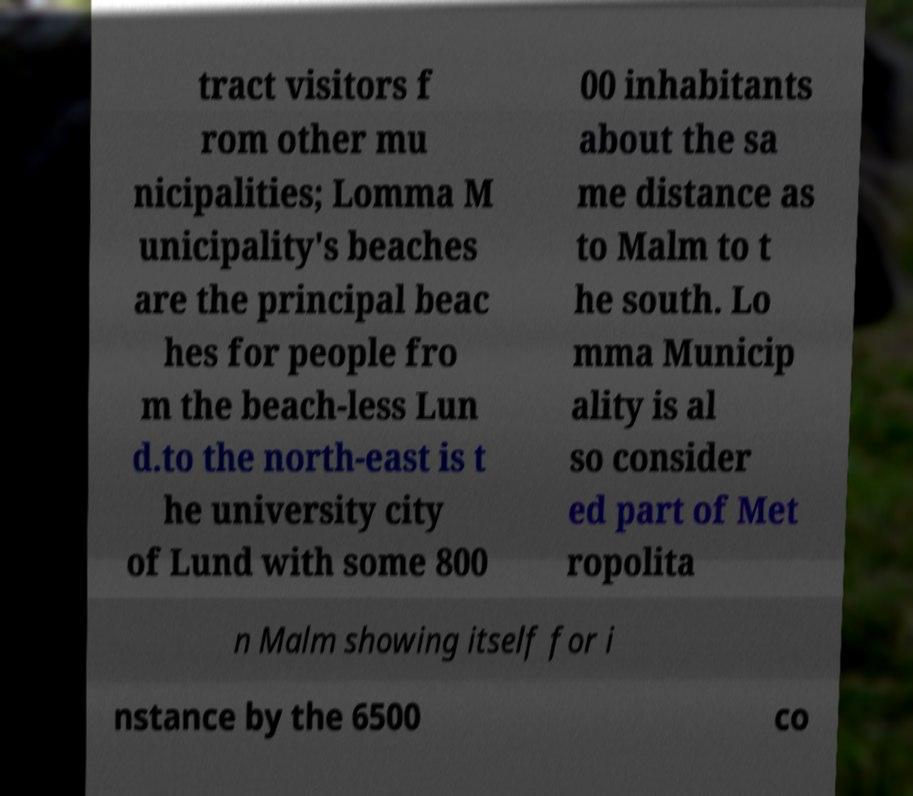Please read and relay the text visible in this image. What does it say? tract visitors f rom other mu nicipalities; Lomma M unicipality's beaches are the principal beac hes for people fro m the beach-less Lun d.to the north-east is t he university city of Lund with some 800 00 inhabitants about the sa me distance as to Malm to t he south. Lo mma Municip ality is al so consider ed part of Met ropolita n Malm showing itself for i nstance by the 6500 co 